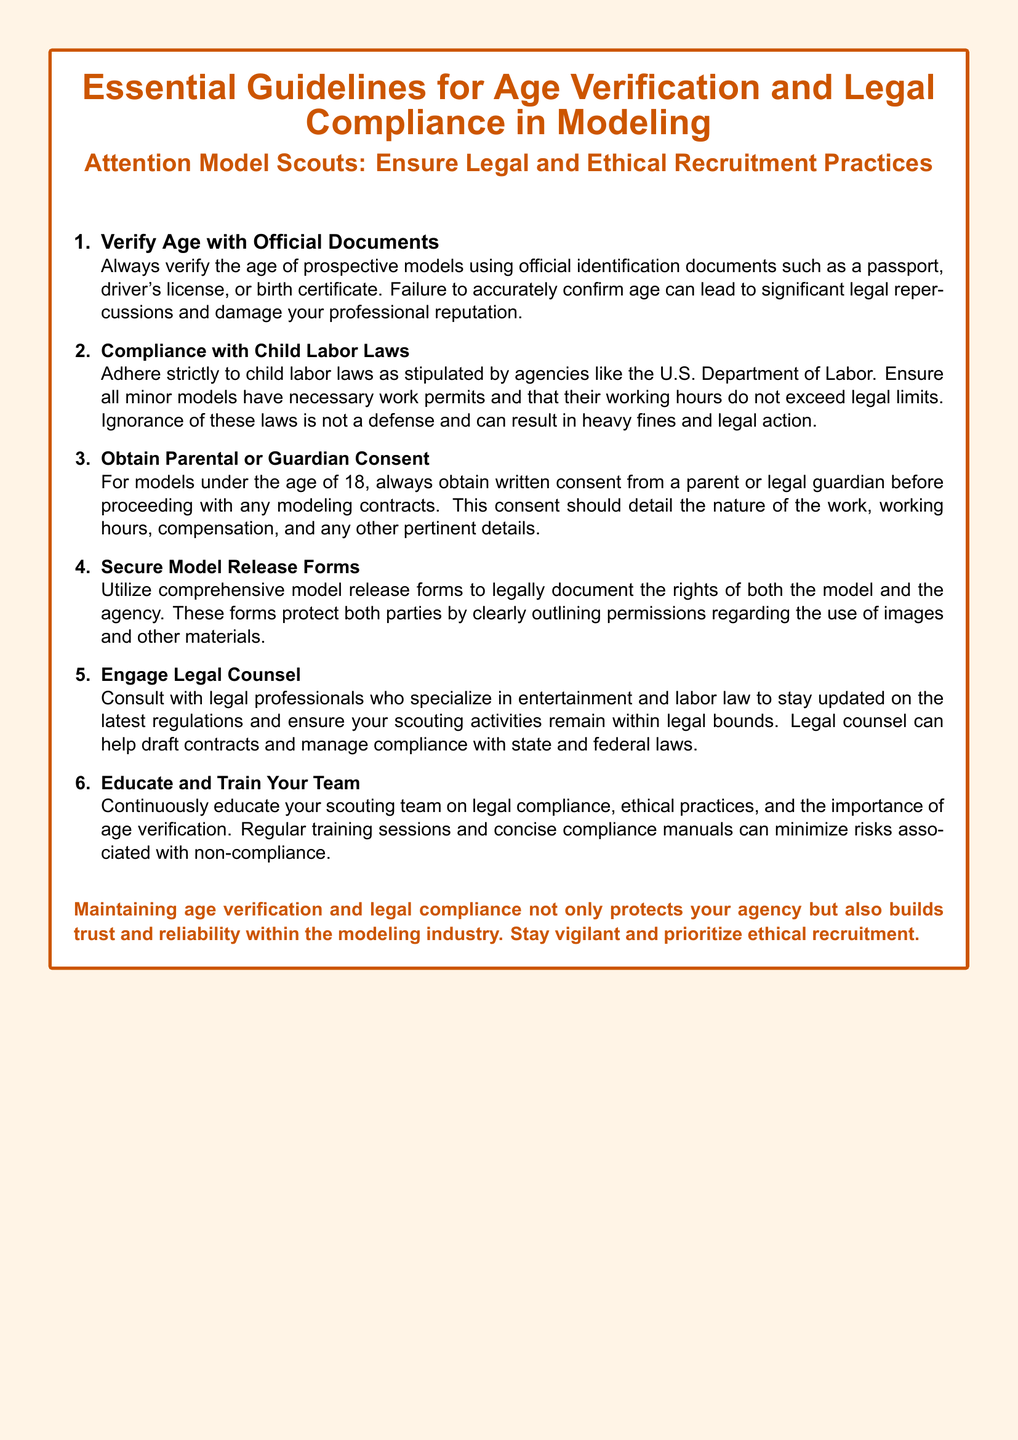What is the main focus of the document? The document emphasizes the importance of age verification and legal compliance in modeling, particularly for model scouts.
Answer: Age verification and legal compliance in modeling What type of documents should be used to verify age? The document advises using official identification documents such as a passport, driver's license, or birth certificate to verify age.
Answer: Official identification documents What must be obtained for models under 18? The document states that written consent from a parent or legal guardian must be obtained before proceeding with contracts for minor models.
Answer: Written consent Who should be consulted for legal compliance? The document recommends engaging legal counsel who specializes in entertainment and labor law for guidance on legal compliance.
Answer: Legal counsel What is the potential consequence of failing to verify age? The document notes that failing to accurately confirm age can lead to significant legal repercussions and damage professional reputation.
Answer: Significant legal repercussions How many essential guidelines are provided in the document? The document outlines six essential guidelines for age verification and legal compliance in modeling.
Answer: Six What is advised to minimize risks related to compliance? The document suggests continuously educating and training the scouting team on legal compliance and ethical practices to minimize risks.
Answer: Educating and training Which laws must model scouts adhere to? Model scouts must adhere to child labor laws, as stipulated by agencies like the U.S. Department of Labor.
Answer: Child labor laws What kind of form should be secured for models? The document highlights the need to utilize comprehensive model release forms to legally document the rights of models and agencies.
Answer: Model release forms 